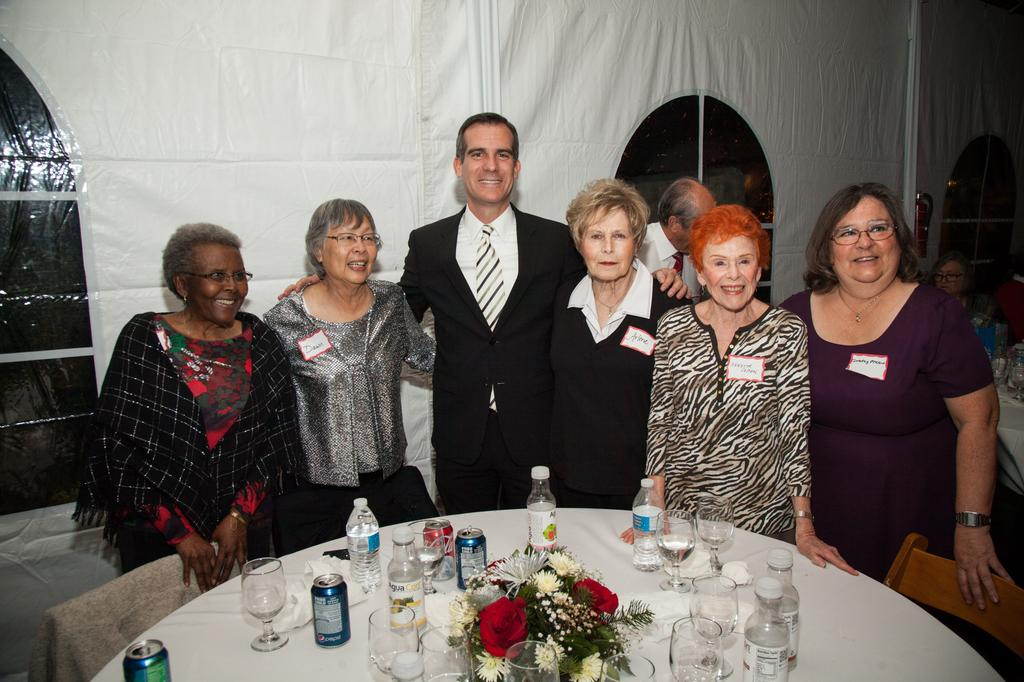What is happening in the center of the image? There are people standing in the center of the image. What is located at the bottom of the image? There is a table at the bottom of the image. What can be found on the table? There are many objects on the table. Can you see any fangs on the people in the image? There is no mention of fangs or any such feature on the people in the image. How many eyes are visible on the table in the image? There is no mention of eyes or any such object on the table in the image. 